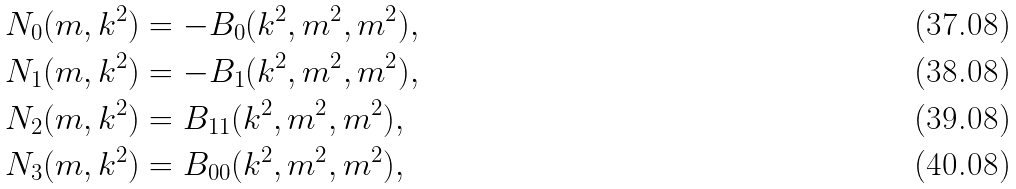Convert formula to latex. <formula><loc_0><loc_0><loc_500><loc_500>N _ { 0 } ( m , k ^ { 2 } ) & = - B _ { 0 } ( k ^ { 2 } , m ^ { 2 } , m ^ { 2 } ) , \\ N _ { 1 } ( m , k ^ { 2 } ) & = - B _ { 1 } ( k ^ { 2 } , m ^ { 2 } , m ^ { 2 } ) , \\ N _ { 2 } ( m , k ^ { 2 } ) & = B _ { 1 1 } ( k ^ { 2 } , m ^ { 2 } , m ^ { 2 } ) , \\ N _ { 3 } ( m , k ^ { 2 } ) & = B _ { 0 0 } ( k ^ { 2 } , m ^ { 2 } , m ^ { 2 } ) ,</formula> 